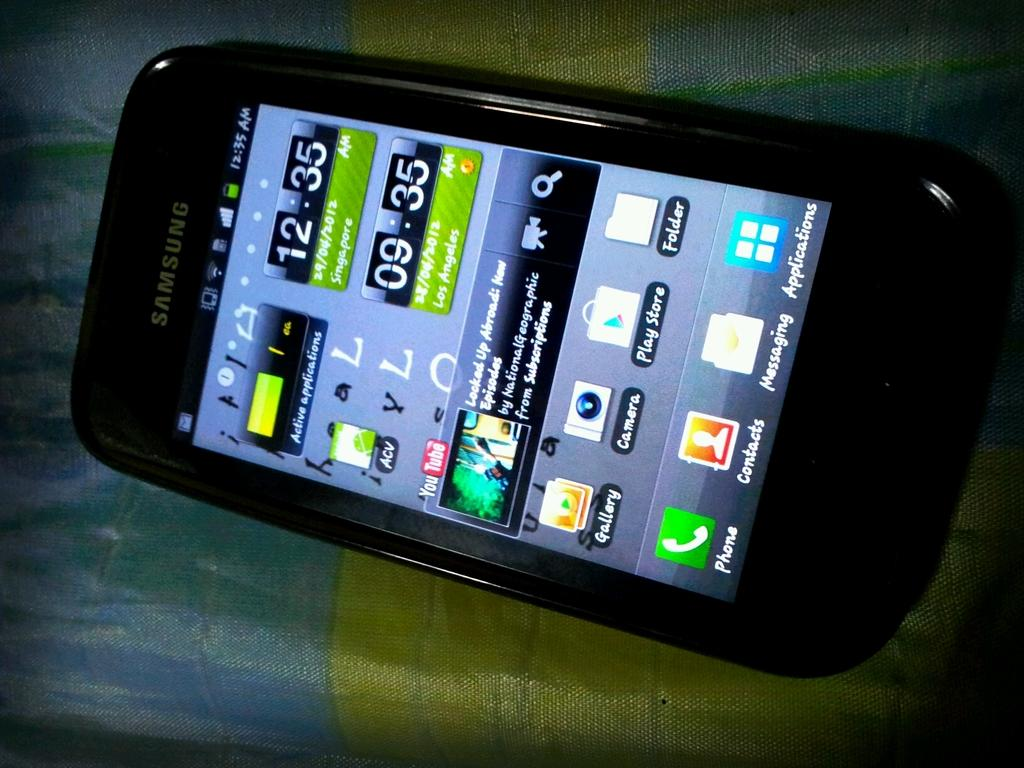<image>
Describe the image concisely. A Samsung brand phone on the phone's main screen. 